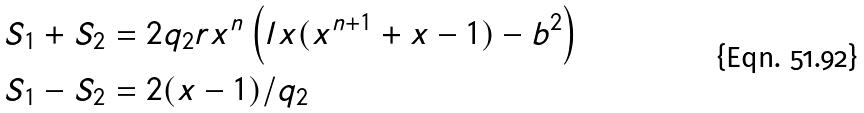<formula> <loc_0><loc_0><loc_500><loc_500>S _ { 1 } + S _ { 2 } & = 2 q _ { 2 } r x ^ { n } \left ( l x ( x ^ { n + 1 } + x - 1 ) - b ^ { 2 } \right ) \\ S _ { 1 } - S _ { 2 } & = 2 ( x - 1 ) / q _ { 2 }</formula> 